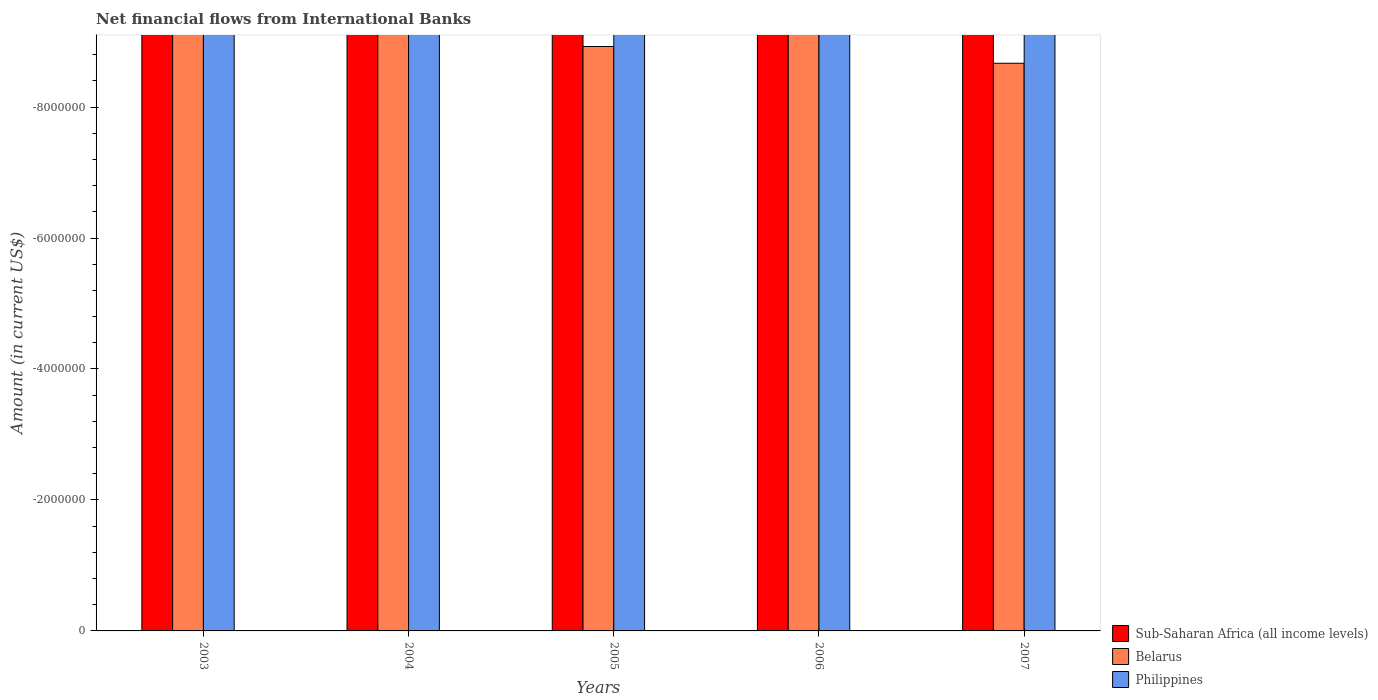How many bars are there on the 5th tick from the left?
Make the answer very short. 0. How many bars are there on the 5th tick from the right?
Give a very brief answer. 0. In how many cases, is the number of bars for a given year not equal to the number of legend labels?
Your answer should be very brief. 5. What is the average net financial aid flows in Sub-Saharan Africa (all income levels) per year?
Your answer should be compact. 0. In how many years, is the net financial aid flows in Philippines greater than -5200000 US$?
Your response must be concise. 0. In how many years, is the net financial aid flows in Belarus greater than the average net financial aid flows in Belarus taken over all years?
Offer a very short reply. 0. How many bars are there?
Provide a short and direct response. 0. How many years are there in the graph?
Provide a succinct answer. 5. How many legend labels are there?
Offer a terse response. 3. How are the legend labels stacked?
Ensure brevity in your answer.  Vertical. What is the title of the graph?
Your answer should be compact. Net financial flows from International Banks. What is the Amount (in current US$) in Philippines in 2003?
Provide a succinct answer. 0. What is the Amount (in current US$) in Belarus in 2004?
Offer a terse response. 0. What is the Amount (in current US$) in Sub-Saharan Africa (all income levels) in 2005?
Offer a terse response. 0. What is the Amount (in current US$) of Belarus in 2005?
Your answer should be compact. 0. What is the Amount (in current US$) in Belarus in 2006?
Your answer should be very brief. 0. What is the Amount (in current US$) in Philippines in 2006?
Your response must be concise. 0. What is the Amount (in current US$) in Belarus in 2007?
Offer a very short reply. 0. What is the total Amount (in current US$) in Sub-Saharan Africa (all income levels) in the graph?
Keep it short and to the point. 0. What is the total Amount (in current US$) of Belarus in the graph?
Ensure brevity in your answer.  0. What is the total Amount (in current US$) in Philippines in the graph?
Provide a succinct answer. 0. What is the average Amount (in current US$) of Sub-Saharan Africa (all income levels) per year?
Provide a succinct answer. 0. What is the average Amount (in current US$) of Philippines per year?
Make the answer very short. 0. 